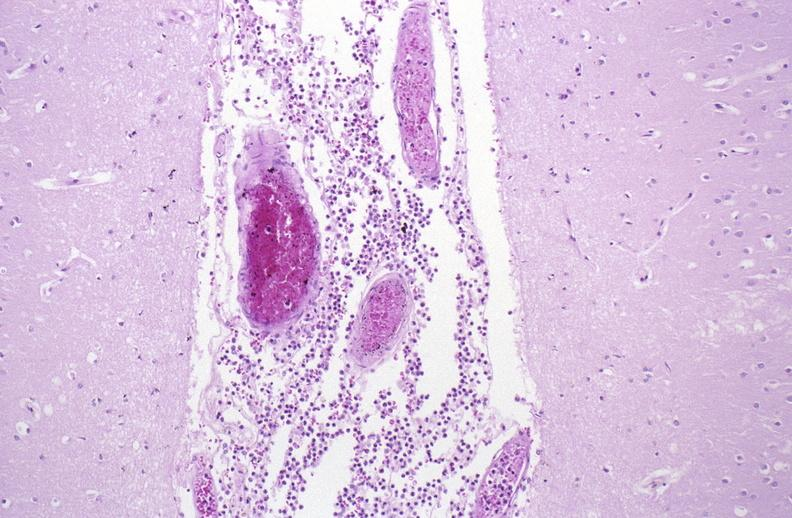does this image show bacterial meningitis?
Answer the question using a single word or phrase. Yes 